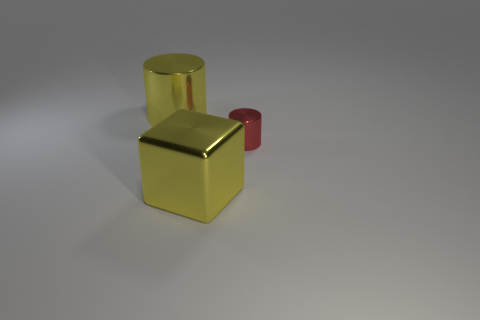What is the size of the metal thing that is the same color as the cube?
Give a very brief answer. Large. How many blocks are large yellow things or small things?
Your response must be concise. 1. Does the big yellow metallic object that is on the left side of the big block have the same shape as the small thing?
Provide a short and direct response. Yes. Are there more cylinders to the left of the red metal cylinder than tiny blue matte things?
Ensure brevity in your answer.  Yes. There is a metal cylinder that is the same size as the yellow shiny block; what is its color?
Offer a terse response. Yellow. What number of things are either big shiny things that are behind the metallic cube or big cyan blocks?
Make the answer very short. 1. The metal thing that is the same color as the large metallic block is what shape?
Offer a terse response. Cylinder. Are there any big yellow objects made of the same material as the yellow cube?
Keep it short and to the point. Yes. There is a cylinder that is behind the red metal cylinder; is there a big yellow thing that is in front of it?
Offer a very short reply. Yes. There is a metal cylinder on the right side of the yellow object that is in front of the large thing that is behind the red metal cylinder; what color is it?
Give a very brief answer. Red. 